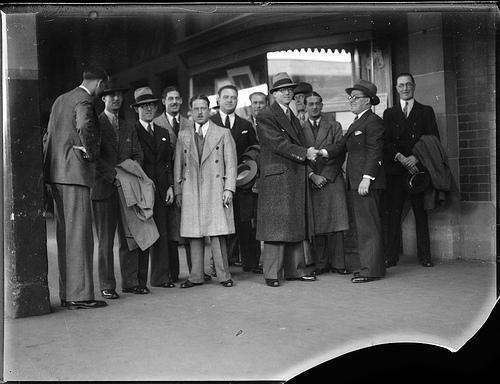How many men are holding their coats?
Give a very brief answer. 2. How many people are in the photo?
Give a very brief answer. 8. How many large giraffes are there?
Give a very brief answer. 0. 